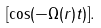Convert formula to latex. <formula><loc_0><loc_0><loc_500><loc_500>[ \cos ( - \Omega ( r ) t ) ] .</formula> 